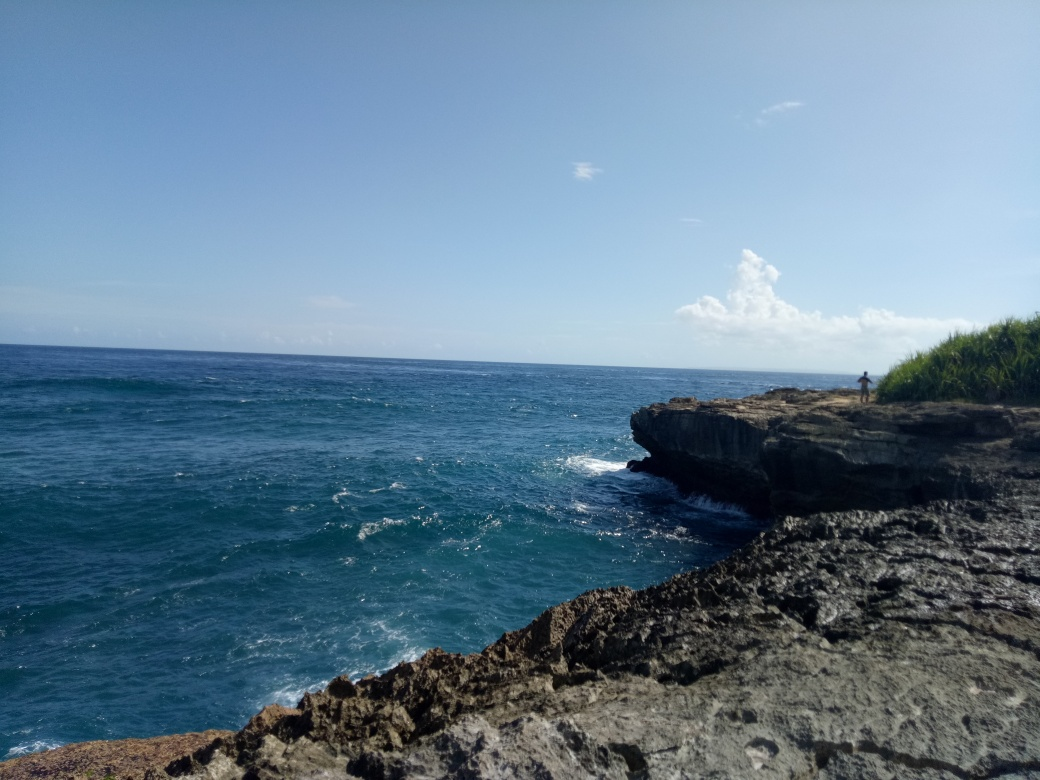Does this location look like it's popular with tourists? This location appears to be relatively serene and unpopulated at the moment the image was taken, indicated by the single person visible at a distance and absence of tourist facilities. Its natural beauty might attract those interested in quieter, picturesque spots. Are there any activities you can suggest for visitors at this site? Visitors here might engage in nature photography, scenic walks along the cliffs, picnicking with panoramic ocean views, or possibly birdwatching, as coastal areas often harbor diverse avian life. 